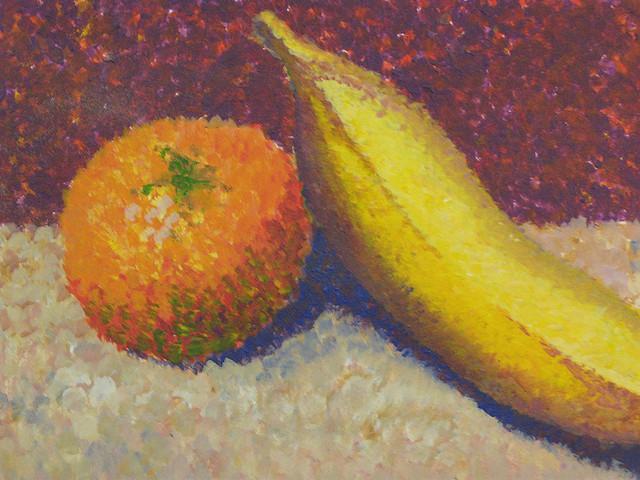How many bananas do you see?
Give a very brief answer. 1. 